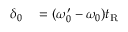<formula> <loc_0><loc_0><loc_500><loc_500>\begin{array} { r l } { \delta _ { 0 } } & = ( \omega _ { 0 } ^ { \prime } - \omega _ { 0 } ) t _ { R } } \end{array}</formula> 